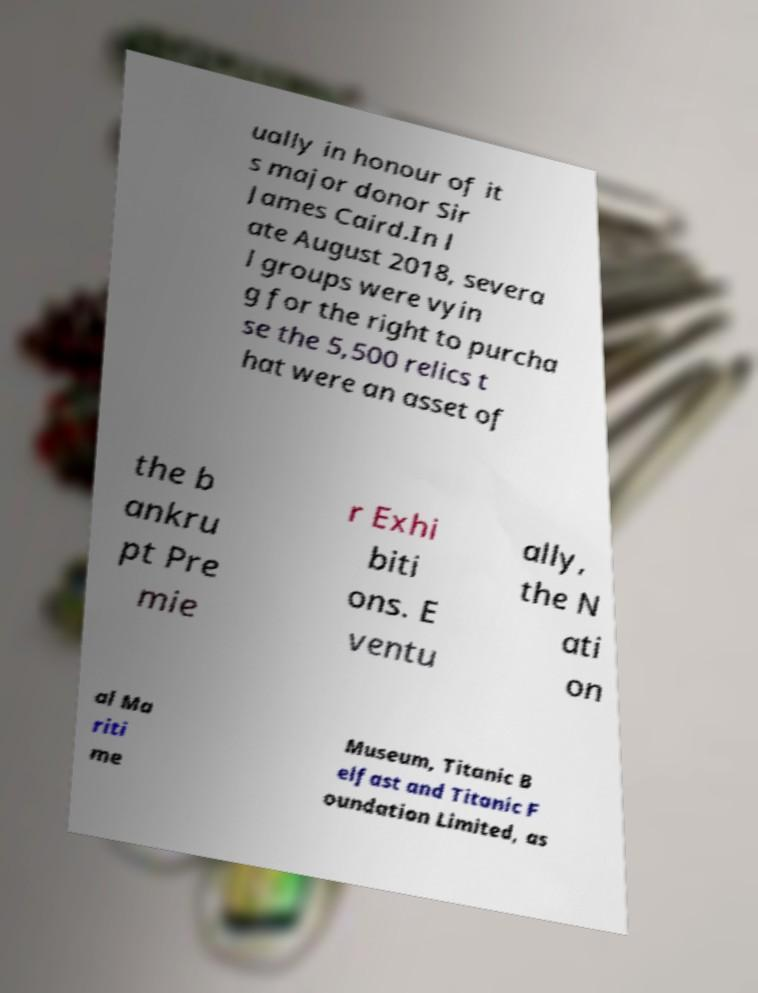Please read and relay the text visible in this image. What does it say? ually in honour of it s major donor Sir James Caird.In l ate August 2018, severa l groups were vyin g for the right to purcha se the 5,500 relics t hat were an asset of the b ankru pt Pre mie r Exhi biti ons. E ventu ally, the N ati on al Ma riti me Museum, Titanic B elfast and Titanic F oundation Limited, as 